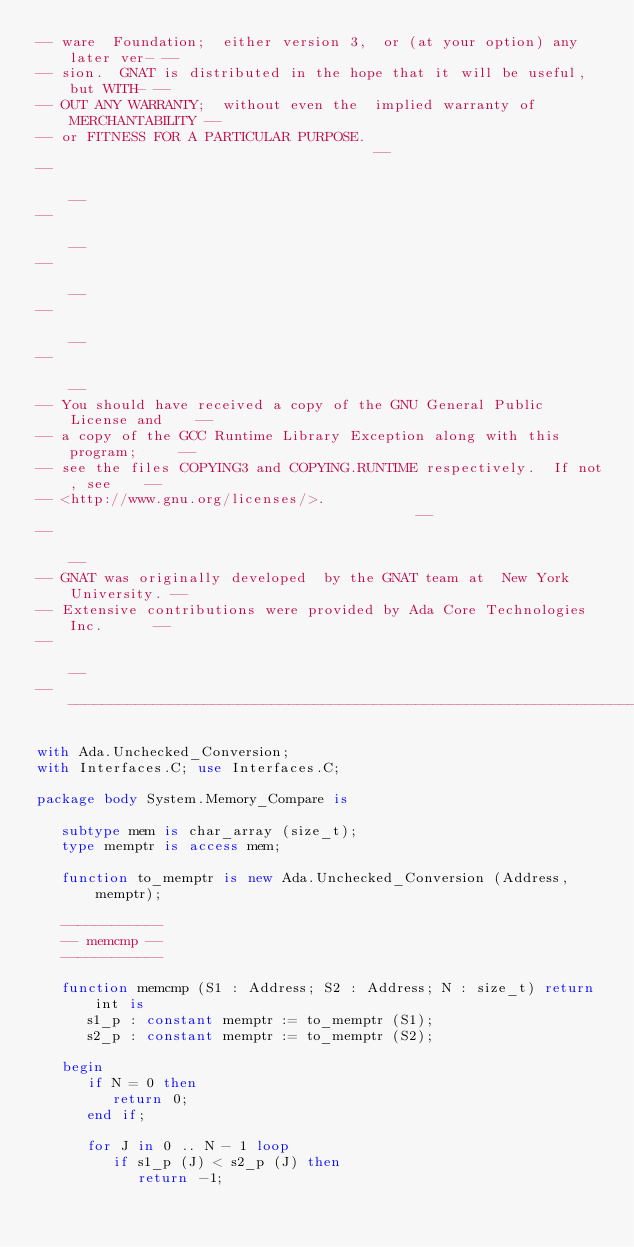<code> <loc_0><loc_0><loc_500><loc_500><_Ada_>-- ware  Foundation;  either version 3,  or (at your option) any later ver- --
-- sion.  GNAT is distributed in the hope that it will be useful, but WITH- --
-- OUT ANY WARRANTY;  without even the  implied warranty of MERCHANTABILITY --
-- or FITNESS FOR A PARTICULAR PURPOSE.                                     --
--                                                                          --
--                                                                          --
--                                                                          --
--                                                                          --
--                                                                          --
-- You should have received a copy of the GNU General Public License and    --
-- a copy of the GCC Runtime Library Exception along with this program;     --
-- see the files COPYING3 and COPYING.RUNTIME respectively.  If not, see    --
-- <http://www.gnu.org/licenses/>.                                          --
--                                                                          --
-- GNAT was originally developed  by the GNAT team at  New York University. --
-- Extensive contributions were provided by Ada Core Technologies Inc.      --
--                                                                          --
------------------------------------------------------------------------------

with Ada.Unchecked_Conversion;
with Interfaces.C; use Interfaces.C;

package body System.Memory_Compare is

   subtype mem is char_array (size_t);
   type memptr is access mem;

   function to_memptr is new Ada.Unchecked_Conversion (Address, memptr);

   ------------
   -- memcmp --
   ------------

   function memcmp (S1 : Address; S2 : Address; N : size_t) return int is
      s1_p : constant memptr := to_memptr (S1);
      s2_p : constant memptr := to_memptr (S2);

   begin
      if N = 0 then
         return 0;
      end if;

      for J in 0 .. N - 1 loop
         if s1_p (J) < s2_p (J) then
            return -1;</code> 